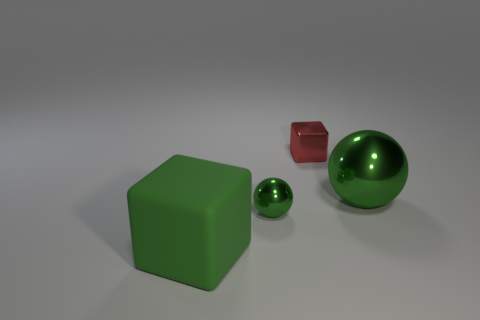Add 1 large red matte cylinders. How many objects exist? 5 Add 1 tiny red things. How many tiny red things exist? 2 Subtract 0 purple spheres. How many objects are left? 4 Subtract all big cyan matte cubes. Subtract all rubber objects. How many objects are left? 3 Add 1 tiny red blocks. How many tiny red blocks are left? 2 